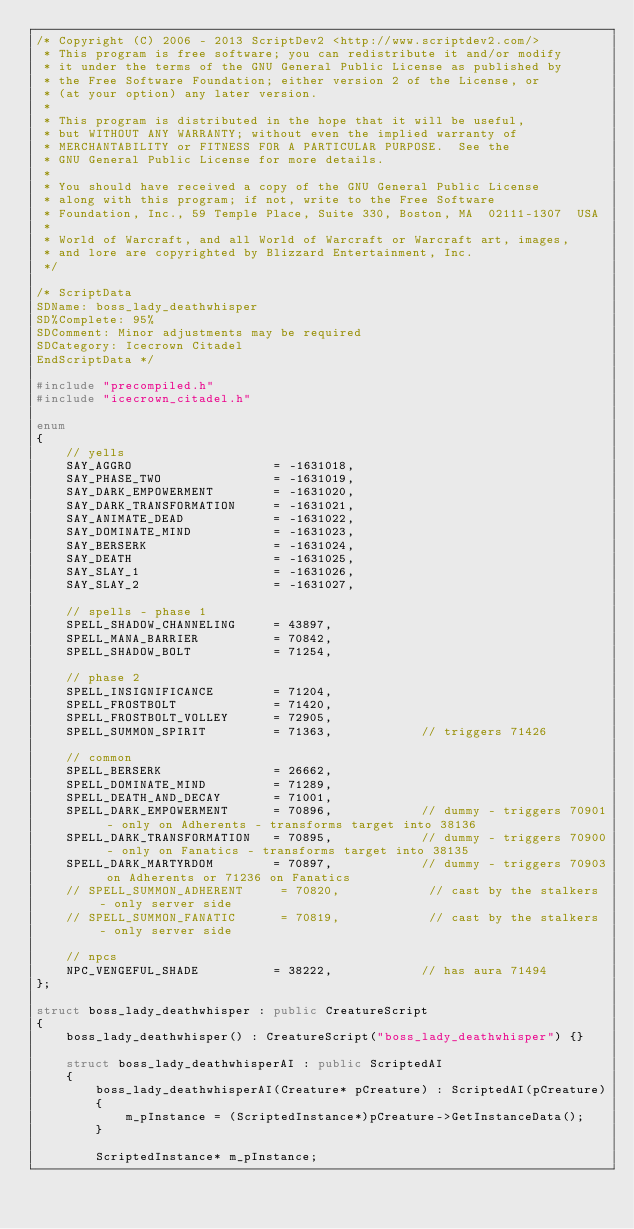Convert code to text. <code><loc_0><loc_0><loc_500><loc_500><_C++_>/* Copyright (C) 2006 - 2013 ScriptDev2 <http://www.scriptdev2.com/>
 * This program is free software; you can redistribute it and/or modify
 * it under the terms of the GNU General Public License as published by
 * the Free Software Foundation; either version 2 of the License, or
 * (at your option) any later version.
 *
 * This program is distributed in the hope that it will be useful,
 * but WITHOUT ANY WARRANTY; without even the implied warranty of
 * MERCHANTABILITY or FITNESS FOR A PARTICULAR PURPOSE.  See the
 * GNU General Public License for more details.
 *
 * You should have received a copy of the GNU General Public License
 * along with this program; if not, write to the Free Software
 * Foundation, Inc., 59 Temple Place, Suite 330, Boston, MA  02111-1307  USA
 *
 * World of Warcraft, and all World of Warcraft or Warcraft art, images,
 * and lore are copyrighted by Blizzard Entertainment, Inc.
 */

/* ScriptData
SDName: boss_lady_deathwhisper
SD%Complete: 95%
SDComment: Minor adjustments may be required
SDCategory: Icecrown Citadel
EndScriptData */

#include "precompiled.h"
#include "icecrown_citadel.h"

enum
{
    // yells
    SAY_AGGRO                   = -1631018,
    SAY_PHASE_TWO               = -1631019,
    SAY_DARK_EMPOWERMENT        = -1631020,
    SAY_DARK_TRANSFORMATION     = -1631021,
    SAY_ANIMATE_DEAD            = -1631022,
    SAY_DOMINATE_MIND           = -1631023,
    SAY_BERSERK                 = -1631024,
    SAY_DEATH                   = -1631025,
    SAY_SLAY_1                  = -1631026,
    SAY_SLAY_2                  = -1631027,

    // spells - phase 1
    SPELL_SHADOW_CHANNELING     = 43897,
    SPELL_MANA_BARRIER          = 70842,
    SPELL_SHADOW_BOLT           = 71254,

    // phase 2
    SPELL_INSIGNIFICANCE        = 71204,
    SPELL_FROSTBOLT             = 71420,
    SPELL_FROSTBOLT_VOLLEY      = 72905,
    SPELL_SUMMON_SPIRIT         = 71363,            // triggers 71426

    // common
    SPELL_BERSERK               = 26662,
    SPELL_DOMINATE_MIND         = 71289,
    SPELL_DEATH_AND_DECAY       = 71001,
    SPELL_DARK_EMPOWERMENT      = 70896,            // dummy - triggers 70901 - only on Adherents - transforms target into 38136
    SPELL_DARK_TRANSFORMATION   = 70895,            // dummy - triggers 70900 - only on Fanatics - transforms target into 38135
    SPELL_DARK_MARTYRDOM        = 70897,            // dummy - triggers 70903 on Adherents or 71236 on Fanatics
    // SPELL_SUMMON_ADHERENT     = 70820,            // cast by the stalkers - only server side
    // SPELL_SUMMON_FANATIC      = 70819,            // cast by the stalkers - only server side

    // npcs
    NPC_VENGEFUL_SHADE          = 38222,            // has aura 71494
};

struct boss_lady_deathwhisper : public CreatureScript
{
    boss_lady_deathwhisper() : CreatureScript("boss_lady_deathwhisper") {}

    struct boss_lady_deathwhisperAI : public ScriptedAI
    {
        boss_lady_deathwhisperAI(Creature* pCreature) : ScriptedAI(pCreature)
        {
            m_pInstance = (ScriptedInstance*)pCreature->GetInstanceData();
        }

        ScriptedInstance* m_pInstance;
</code> 